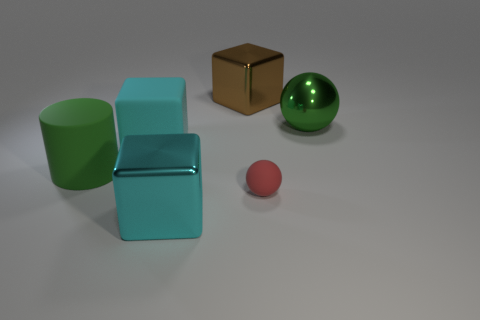What number of cylinders are large shiny things or small red rubber objects?
Your response must be concise. 0. What number of green cylinders are the same material as the big ball?
Ensure brevity in your answer.  0. The object that is the same color as the big sphere is what shape?
Your response must be concise. Cylinder. What is the object that is behind the tiny matte sphere and right of the brown object made of?
Keep it short and to the point. Metal. What is the shape of the green thing behind the big green cylinder?
Your answer should be very brief. Sphere. There is a big green object that is on the right side of the cube that is behind the big sphere; what is its shape?
Offer a very short reply. Sphere. Is there a tiny red rubber object of the same shape as the large cyan matte thing?
Provide a short and direct response. No. The brown metal object that is the same size as the green metallic thing is what shape?
Ensure brevity in your answer.  Cube. Are there any red rubber balls to the right of the big green thing that is right of the shiny block that is behind the metal sphere?
Keep it short and to the point. No. Is there a green metallic block of the same size as the green sphere?
Your answer should be very brief. No. 